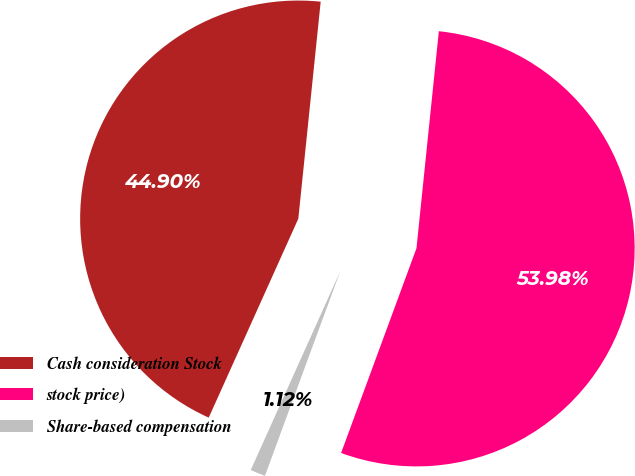<chart> <loc_0><loc_0><loc_500><loc_500><pie_chart><fcel>Cash consideration Stock<fcel>stock price)<fcel>Share-based compensation<nl><fcel>44.9%<fcel>53.98%<fcel>1.12%<nl></chart> 